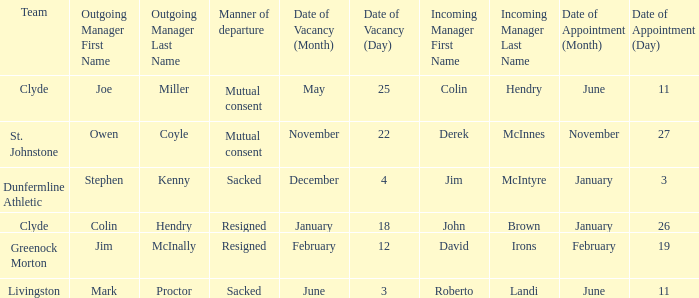Tell me the manner of departure for 3 january date of appointment Sacked. 